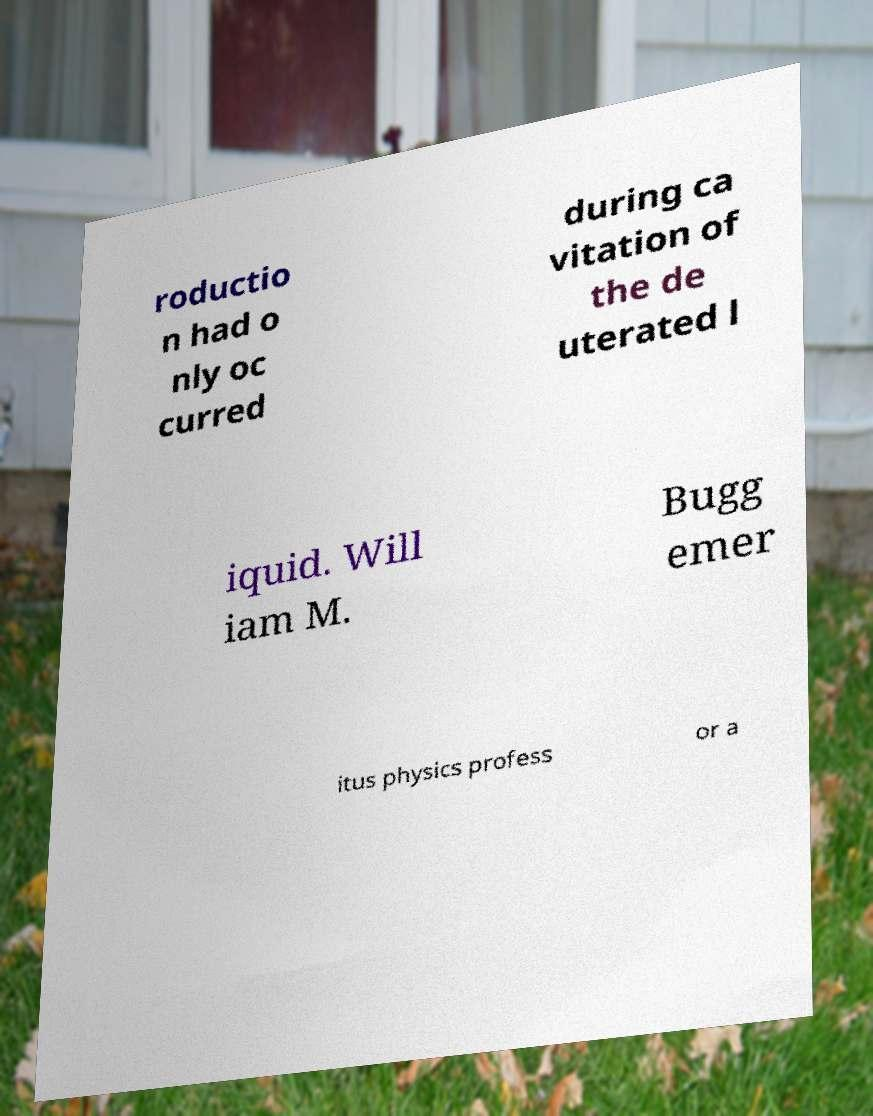I need the written content from this picture converted into text. Can you do that? roductio n had o nly oc curred during ca vitation of the de uterated l iquid. Will iam M. Bugg emer itus physics profess or a 